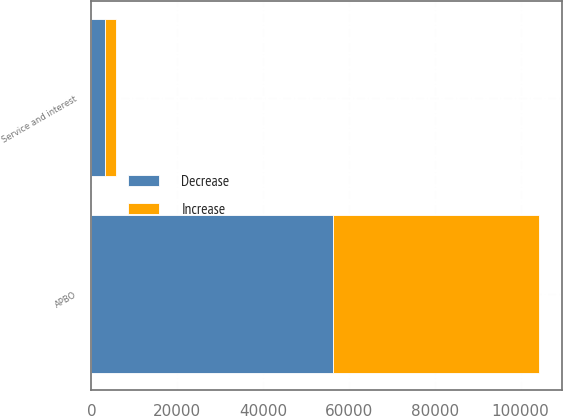Convert chart. <chart><loc_0><loc_0><loc_500><loc_500><stacked_bar_chart><ecel><fcel>APBO<fcel>Service and interest<nl><fcel>Decrease<fcel>56383<fcel>3113<nl><fcel>Increase<fcel>47972<fcel>2594<nl></chart> 